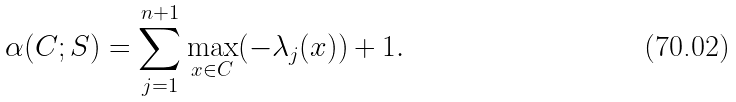<formula> <loc_0><loc_0><loc_500><loc_500>\alpha ( C ; S ) = \sum _ { j = 1 } ^ { n + 1 } \max _ { x \in C } ( - \lambda _ { j } ( x ) ) + 1 .</formula> 